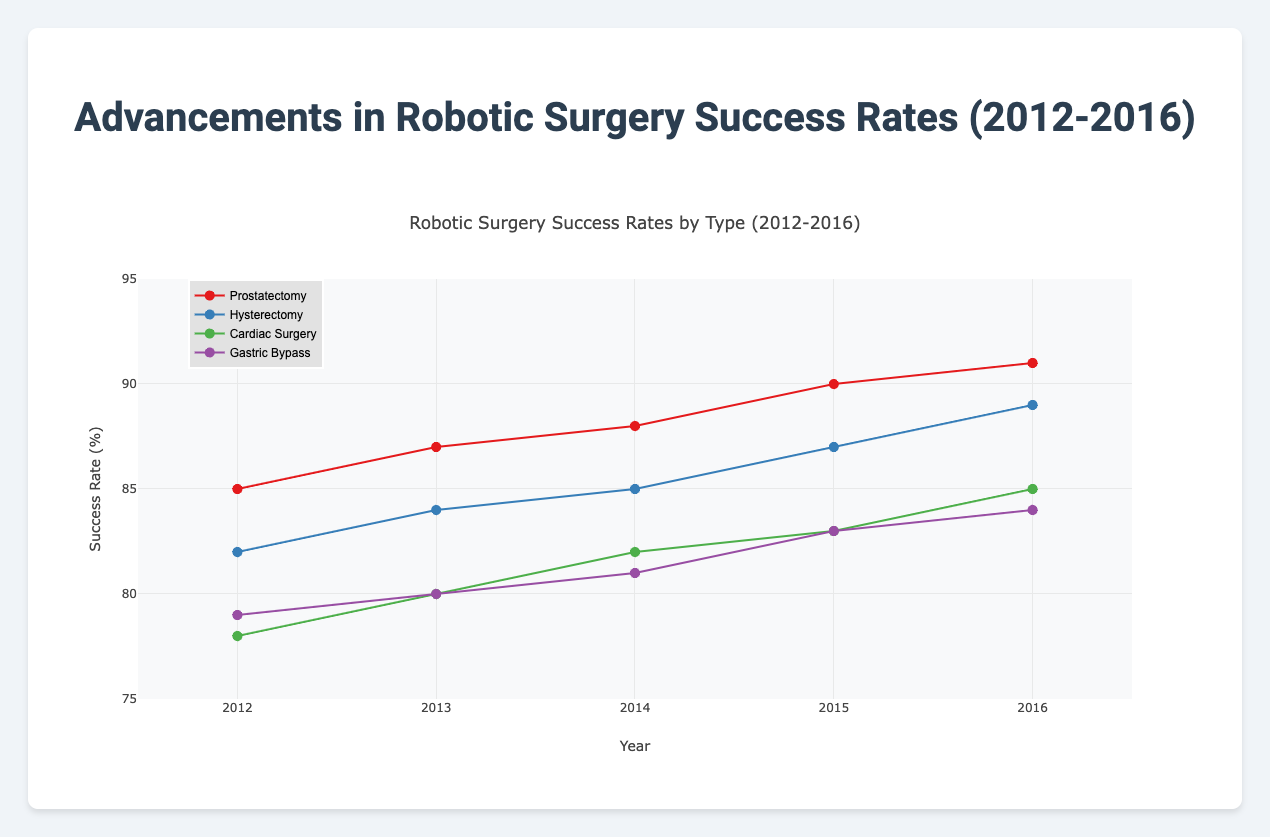How many different surgery types are represented in the figure? By examining the legend or data points' colors and markers, we can count the distinct surgery types.
Answer: Four What is the highest recorded success rate for Prostatectomy during the years shown? Locate the data points for Prostatectomy on the graph and find the highest value among them. It’s easiest to refer to the trend line.
Answer: 91% Between 2012 and 2016, did the success rates for Hysterectomy increase, decrease, or stay the same? Analyze the data points for Hysterectomy in the plotted graph from 2012 to 2016 to determine the trend.
Answer: Increase Which surgery type had the lowest success rate in 2012? Look at the data points for each surgery type in the year 2012 and find the lowest value.
Answer: Cardiac Surgery By how much did the success rate for Cardiac Surgery improve from 2012 to 2016? Subtract the success rate of Cardiac Surgery in 2012 from the rate in 2016 (85 - 78 = 7%).
Answer: 7% Comparing 2015, which surgery type had a higher success rate: Prostatectomy or Gastric Bypass? Observe the data points for both Prostatectomy and Gastric Bypass in 2015 and compare their success rates.
Answer: Prostatectomy What is the average success rate for Hysterectomy from 2012 to 2016? Sum the success rates of Hysterectomy from 2012 to 2016 and divide by the number of years (82 + 84 + 85 + 87 + 89) / 5 = 85.4%.
Answer: 85.4% Which surgery type shows the steepest positive trend in success rates? Compare the slopes of the trend lines for each surgery type generated on the plot, focusing on the one with the steepest upward slope.
Answer: Prostatectomy In the figure, do we observe any surgery type with a declining trend in success rates? Evaluate the trend lines for all surgery types and verify if any line trends downwards for the years from 2012 to 2016.
Answer: No What can be inferred about the general trend of robotic surgery success rates from 2012 to 2016? By inspecting the overall movement of the trend lines for all surgery types, we can determine whether the general trend is upward or downward.
Answer: Upward 